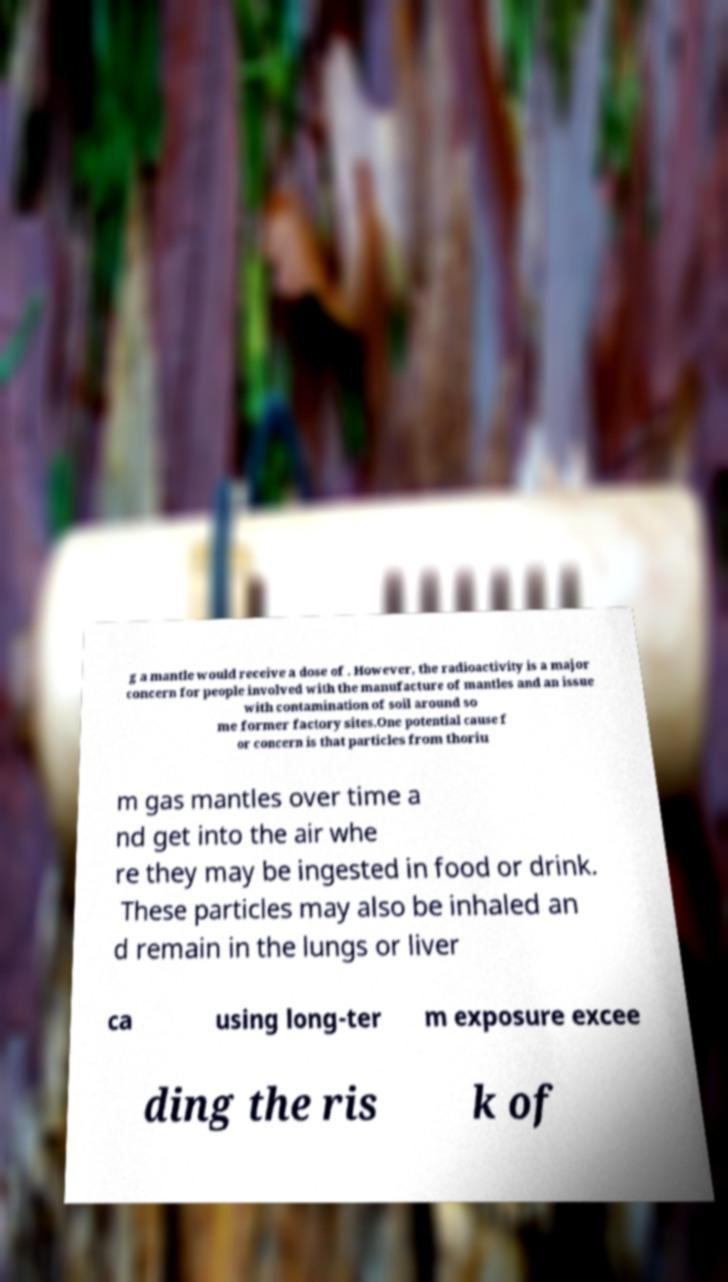There's text embedded in this image that I need extracted. Can you transcribe it verbatim? g a mantle would receive a dose of . However, the radioactivity is a major concern for people involved with the manufacture of mantles and an issue with contamination of soil around so me former factory sites.One potential cause f or concern is that particles from thoriu m gas mantles over time a nd get into the air whe re they may be ingested in food or drink. These particles may also be inhaled an d remain in the lungs or liver ca using long-ter m exposure excee ding the ris k of 